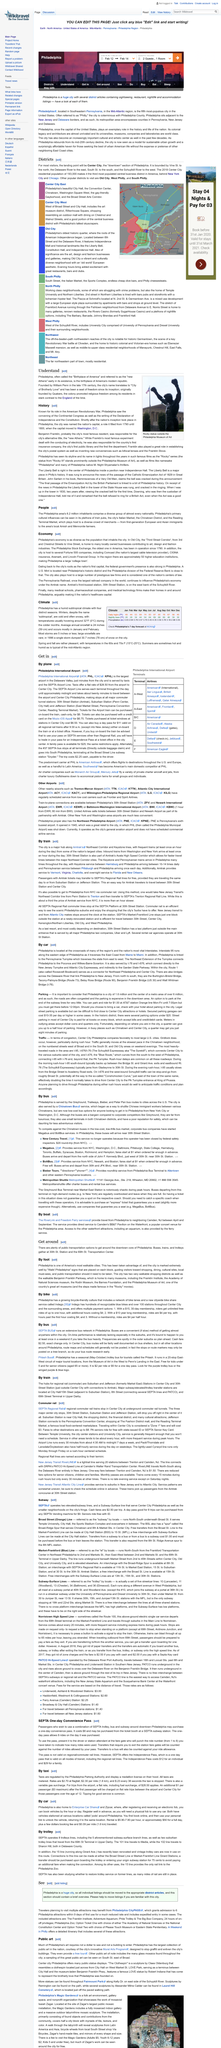Highlight a few significant elements in this photo. SEPTA operates 8 trolleys lines. The SEPTA One-day Convenience pass can be purchased from the ticket booths located at all SEPTA subway stations. The Independence Pass is a one-day pass that provides access to all modes of transportation, including the regional rail line, for exploring the Independence National Historical Park in Philadelphia. The major center city stops on SEPTA Regional rail Commuter rail trains are 30th Street Station, Suburban Station, and Jefferson Station. Inbound trains from Washington and New York arrive frequently during the day, at least once an hour. 